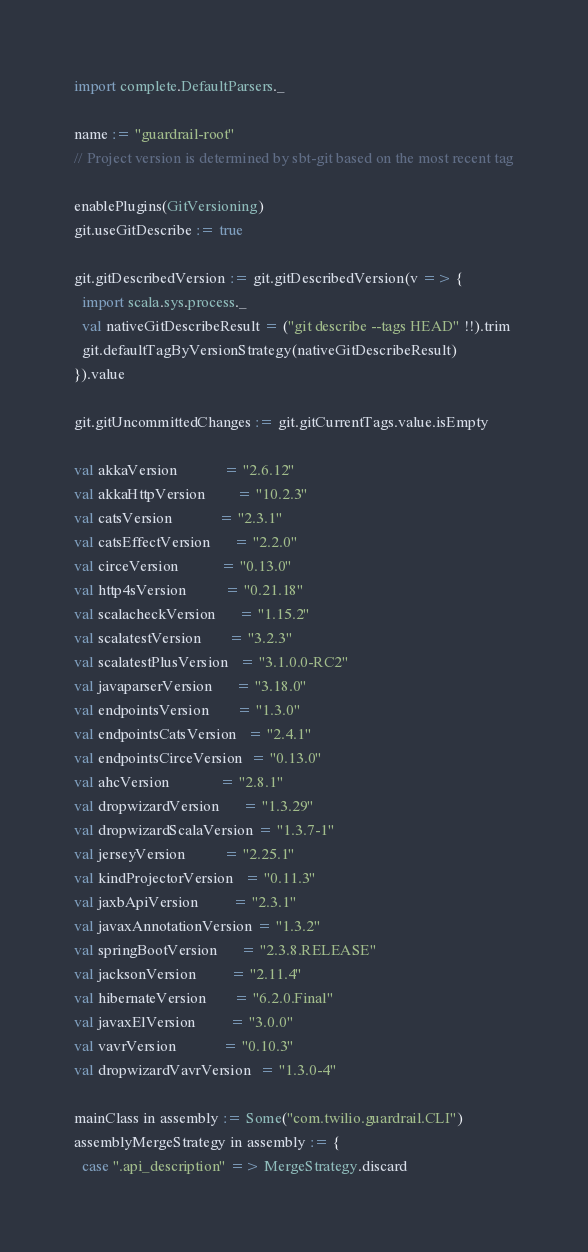<code> <loc_0><loc_0><loc_500><loc_500><_Scala_>import complete.DefaultParsers._

name := "guardrail-root"
// Project version is determined by sbt-git based on the most recent tag

enablePlugins(GitVersioning)
git.useGitDescribe := true

git.gitDescribedVersion := git.gitDescribedVersion(v => {
  import scala.sys.process._
  val nativeGitDescribeResult = ("git describe --tags HEAD" !!).trim
  git.defaultTagByVersionStrategy(nativeGitDescribeResult)
}).value

git.gitUncommittedChanges := git.gitCurrentTags.value.isEmpty

val akkaVersion            = "2.6.12"
val akkaHttpVersion        = "10.2.3"
val catsVersion            = "2.3.1"
val catsEffectVersion      = "2.2.0"
val circeVersion           = "0.13.0"
val http4sVersion          = "0.21.18"
val scalacheckVersion      = "1.15.2"
val scalatestVersion       = "3.2.3"
val scalatestPlusVersion   = "3.1.0.0-RC2"
val javaparserVersion      = "3.18.0"
val endpointsVersion       = "1.3.0"
val endpointsCatsVersion   = "2.4.1"
val endpointsCirceVersion  = "0.13.0"
val ahcVersion             = "2.8.1"
val dropwizardVersion      = "1.3.29"
val dropwizardScalaVersion = "1.3.7-1"
val jerseyVersion          = "2.25.1"
val kindProjectorVersion   = "0.11.3"
val jaxbApiVersion         = "2.3.1"
val javaxAnnotationVersion = "1.3.2"
val springBootVersion      = "2.3.8.RELEASE"
val jacksonVersion         = "2.11.4"
val hibernateVersion       = "6.2.0.Final"
val javaxElVersion         = "3.0.0"
val vavrVersion            = "0.10.3"
val dropwizardVavrVersion  = "1.3.0-4"

mainClass in assembly := Some("com.twilio.guardrail.CLI")
assemblyMergeStrategy in assembly := {
  case ".api_description" => MergeStrategy.discard</code> 